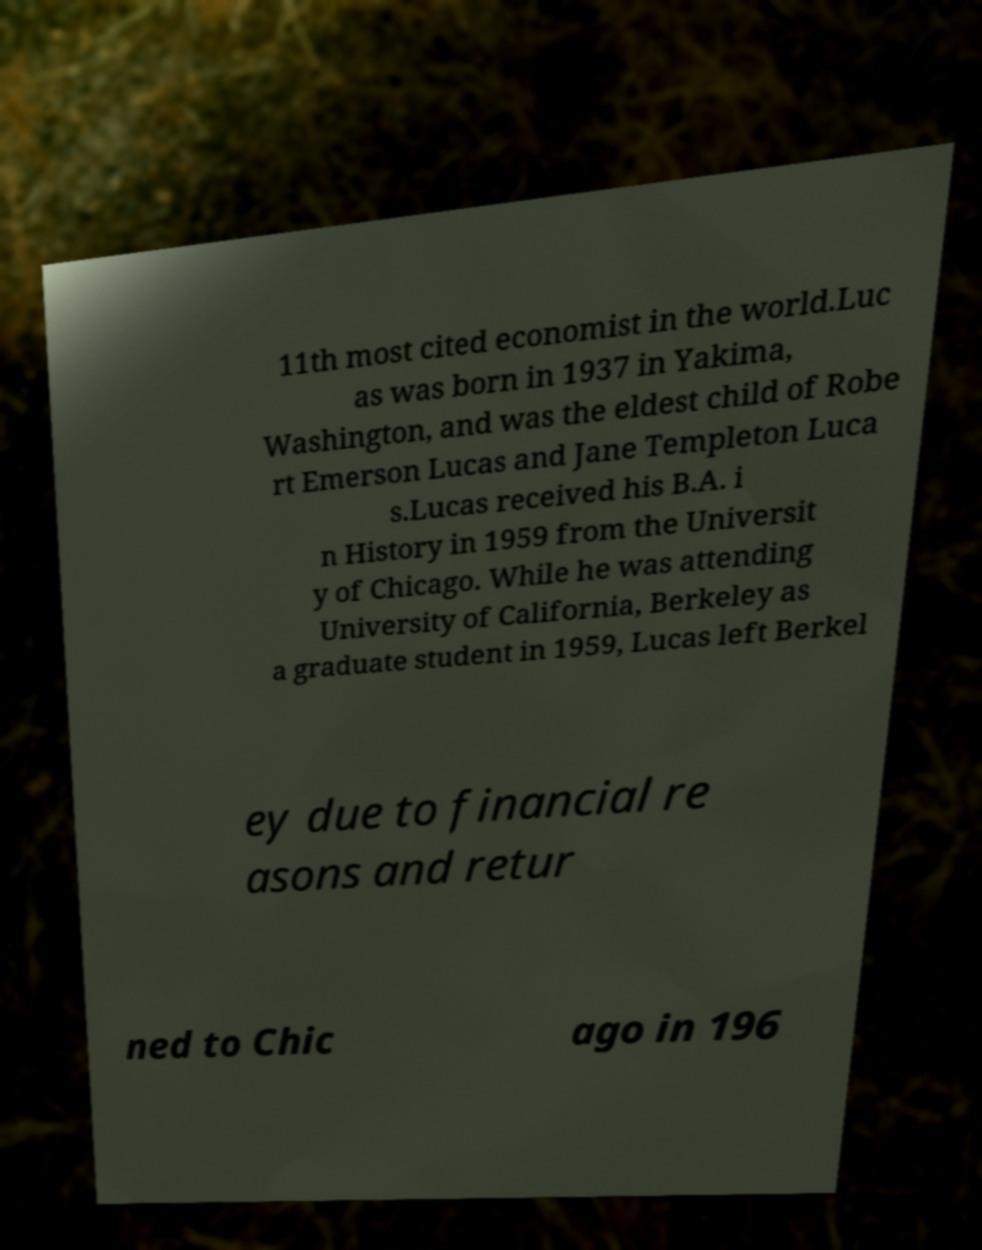Please read and relay the text visible in this image. What does it say? 11th most cited economist in the world.Luc as was born in 1937 in Yakima, Washington, and was the eldest child of Robe rt Emerson Lucas and Jane Templeton Luca s.Lucas received his B.A. i n History in 1959 from the Universit y of Chicago. While he was attending University of California, Berkeley as a graduate student in 1959, Lucas left Berkel ey due to financial re asons and retur ned to Chic ago in 196 